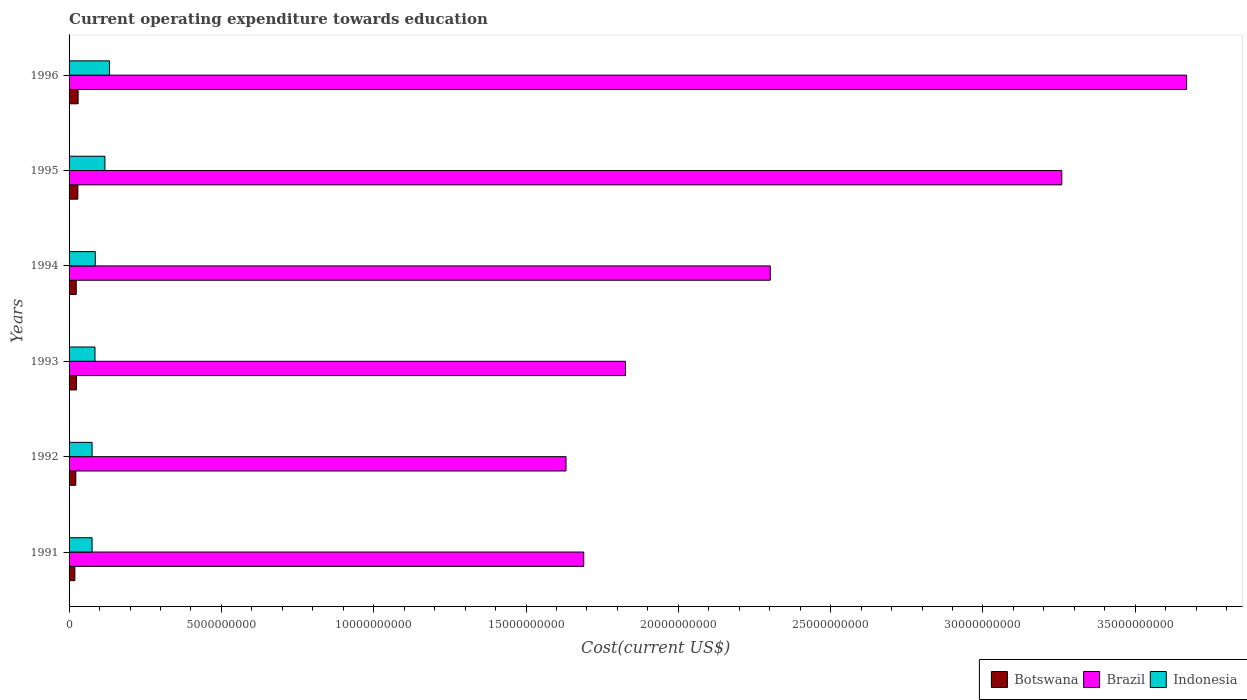Are the number of bars per tick equal to the number of legend labels?
Provide a succinct answer. Yes. Are the number of bars on each tick of the Y-axis equal?
Your answer should be very brief. Yes. What is the label of the 3rd group of bars from the top?
Your answer should be very brief. 1994. What is the expenditure towards education in Botswana in 1993?
Keep it short and to the point. 2.46e+08. Across all years, what is the maximum expenditure towards education in Brazil?
Ensure brevity in your answer.  3.67e+1. Across all years, what is the minimum expenditure towards education in Brazil?
Provide a short and direct response. 1.63e+1. In which year was the expenditure towards education in Indonesia maximum?
Ensure brevity in your answer.  1996. In which year was the expenditure towards education in Botswana minimum?
Ensure brevity in your answer.  1991. What is the total expenditure towards education in Brazil in the graph?
Your answer should be very brief. 1.44e+11. What is the difference between the expenditure towards education in Indonesia in 1993 and that in 1996?
Make the answer very short. -4.77e+08. What is the difference between the expenditure towards education in Indonesia in 1992 and the expenditure towards education in Brazil in 1991?
Your response must be concise. -1.61e+1. What is the average expenditure towards education in Indonesia per year?
Keep it short and to the point. 9.55e+08. In the year 1992, what is the difference between the expenditure towards education in Brazil and expenditure towards education in Indonesia?
Give a very brief answer. 1.56e+1. What is the ratio of the expenditure towards education in Botswana in 1992 to that in 1994?
Keep it short and to the point. 0.94. What is the difference between the highest and the second highest expenditure towards education in Indonesia?
Provide a short and direct response. 1.51e+08. What is the difference between the highest and the lowest expenditure towards education in Botswana?
Offer a terse response. 1.07e+08. Is the sum of the expenditure towards education in Indonesia in 1991 and 1996 greater than the maximum expenditure towards education in Botswana across all years?
Ensure brevity in your answer.  Yes. What does the 2nd bar from the top in 1995 represents?
Provide a succinct answer. Brazil. What does the 1st bar from the bottom in 1992 represents?
Ensure brevity in your answer.  Botswana. Is it the case that in every year, the sum of the expenditure towards education in Indonesia and expenditure towards education in Brazil is greater than the expenditure towards education in Botswana?
Keep it short and to the point. Yes. What is the difference between two consecutive major ticks on the X-axis?
Ensure brevity in your answer.  5.00e+09. Does the graph contain any zero values?
Ensure brevity in your answer.  No. Where does the legend appear in the graph?
Offer a terse response. Bottom right. How are the legend labels stacked?
Your answer should be very brief. Horizontal. What is the title of the graph?
Your answer should be compact. Current operating expenditure towards education. Does "Gabon" appear as one of the legend labels in the graph?
Give a very brief answer. No. What is the label or title of the X-axis?
Your answer should be very brief. Cost(current US$). What is the Cost(current US$) in Botswana in 1991?
Make the answer very short. 1.90e+08. What is the Cost(current US$) of Brazil in 1991?
Make the answer very short. 1.69e+1. What is the Cost(current US$) in Indonesia in 1991?
Ensure brevity in your answer.  7.55e+08. What is the Cost(current US$) in Botswana in 1992?
Offer a terse response. 2.21e+08. What is the Cost(current US$) of Brazil in 1992?
Your answer should be very brief. 1.63e+1. What is the Cost(current US$) of Indonesia in 1992?
Your answer should be compact. 7.56e+08. What is the Cost(current US$) in Botswana in 1993?
Your response must be concise. 2.46e+08. What is the Cost(current US$) of Brazil in 1993?
Provide a succinct answer. 1.83e+1. What is the Cost(current US$) in Indonesia in 1993?
Give a very brief answer. 8.51e+08. What is the Cost(current US$) of Botswana in 1994?
Your answer should be very brief. 2.35e+08. What is the Cost(current US$) in Brazil in 1994?
Provide a succinct answer. 2.30e+1. What is the Cost(current US$) in Indonesia in 1994?
Provide a short and direct response. 8.61e+08. What is the Cost(current US$) in Botswana in 1995?
Your answer should be compact. 2.89e+08. What is the Cost(current US$) of Brazil in 1995?
Make the answer very short. 3.26e+1. What is the Cost(current US$) in Indonesia in 1995?
Offer a terse response. 1.18e+09. What is the Cost(current US$) of Botswana in 1996?
Offer a very short reply. 2.97e+08. What is the Cost(current US$) of Brazil in 1996?
Make the answer very short. 3.67e+1. What is the Cost(current US$) of Indonesia in 1996?
Offer a terse response. 1.33e+09. Across all years, what is the maximum Cost(current US$) of Botswana?
Provide a succinct answer. 2.97e+08. Across all years, what is the maximum Cost(current US$) in Brazil?
Offer a terse response. 3.67e+1. Across all years, what is the maximum Cost(current US$) in Indonesia?
Provide a succinct answer. 1.33e+09. Across all years, what is the minimum Cost(current US$) in Botswana?
Provide a short and direct response. 1.90e+08. Across all years, what is the minimum Cost(current US$) of Brazil?
Your response must be concise. 1.63e+1. Across all years, what is the minimum Cost(current US$) of Indonesia?
Offer a very short reply. 7.55e+08. What is the total Cost(current US$) in Botswana in the graph?
Provide a succinct answer. 1.48e+09. What is the total Cost(current US$) in Brazil in the graph?
Your response must be concise. 1.44e+11. What is the total Cost(current US$) in Indonesia in the graph?
Make the answer very short. 5.73e+09. What is the difference between the Cost(current US$) of Botswana in 1991 and that in 1992?
Make the answer very short. -3.12e+07. What is the difference between the Cost(current US$) of Brazil in 1991 and that in 1992?
Provide a succinct answer. 5.82e+08. What is the difference between the Cost(current US$) of Indonesia in 1991 and that in 1992?
Your answer should be compact. -7.18e+05. What is the difference between the Cost(current US$) of Botswana in 1991 and that in 1993?
Offer a very short reply. -5.54e+07. What is the difference between the Cost(current US$) in Brazil in 1991 and that in 1993?
Offer a terse response. -1.37e+09. What is the difference between the Cost(current US$) of Indonesia in 1991 and that in 1993?
Your response must be concise. -9.61e+07. What is the difference between the Cost(current US$) of Botswana in 1991 and that in 1994?
Offer a terse response. -4.50e+07. What is the difference between the Cost(current US$) of Brazil in 1991 and that in 1994?
Keep it short and to the point. -6.12e+09. What is the difference between the Cost(current US$) of Indonesia in 1991 and that in 1994?
Provide a succinct answer. -1.06e+08. What is the difference between the Cost(current US$) in Botswana in 1991 and that in 1995?
Give a very brief answer. -9.85e+07. What is the difference between the Cost(current US$) in Brazil in 1991 and that in 1995?
Keep it short and to the point. -1.57e+1. What is the difference between the Cost(current US$) in Indonesia in 1991 and that in 1995?
Offer a terse response. -4.22e+08. What is the difference between the Cost(current US$) of Botswana in 1991 and that in 1996?
Your answer should be very brief. -1.07e+08. What is the difference between the Cost(current US$) of Brazil in 1991 and that in 1996?
Offer a very short reply. -1.98e+1. What is the difference between the Cost(current US$) of Indonesia in 1991 and that in 1996?
Your response must be concise. -5.73e+08. What is the difference between the Cost(current US$) of Botswana in 1992 and that in 1993?
Your answer should be very brief. -2.42e+07. What is the difference between the Cost(current US$) in Brazil in 1992 and that in 1993?
Your response must be concise. -1.95e+09. What is the difference between the Cost(current US$) in Indonesia in 1992 and that in 1993?
Provide a succinct answer. -9.54e+07. What is the difference between the Cost(current US$) of Botswana in 1992 and that in 1994?
Your response must be concise. -1.38e+07. What is the difference between the Cost(current US$) of Brazil in 1992 and that in 1994?
Your answer should be compact. -6.71e+09. What is the difference between the Cost(current US$) in Indonesia in 1992 and that in 1994?
Ensure brevity in your answer.  -1.05e+08. What is the difference between the Cost(current US$) of Botswana in 1992 and that in 1995?
Ensure brevity in your answer.  -6.73e+07. What is the difference between the Cost(current US$) of Brazil in 1992 and that in 1995?
Ensure brevity in your answer.  -1.63e+1. What is the difference between the Cost(current US$) in Indonesia in 1992 and that in 1995?
Provide a succinct answer. -4.21e+08. What is the difference between the Cost(current US$) in Botswana in 1992 and that in 1996?
Your response must be concise. -7.54e+07. What is the difference between the Cost(current US$) in Brazil in 1992 and that in 1996?
Make the answer very short. -2.04e+1. What is the difference between the Cost(current US$) of Indonesia in 1992 and that in 1996?
Your answer should be compact. -5.72e+08. What is the difference between the Cost(current US$) of Botswana in 1993 and that in 1994?
Keep it short and to the point. 1.04e+07. What is the difference between the Cost(current US$) of Brazil in 1993 and that in 1994?
Your answer should be very brief. -4.75e+09. What is the difference between the Cost(current US$) of Indonesia in 1993 and that in 1994?
Provide a succinct answer. -9.59e+06. What is the difference between the Cost(current US$) in Botswana in 1993 and that in 1995?
Keep it short and to the point. -4.31e+07. What is the difference between the Cost(current US$) in Brazil in 1993 and that in 1995?
Give a very brief answer. -1.43e+1. What is the difference between the Cost(current US$) in Indonesia in 1993 and that in 1995?
Give a very brief answer. -3.26e+08. What is the difference between the Cost(current US$) of Botswana in 1993 and that in 1996?
Your response must be concise. -5.12e+07. What is the difference between the Cost(current US$) in Brazil in 1993 and that in 1996?
Provide a short and direct response. -1.84e+1. What is the difference between the Cost(current US$) of Indonesia in 1993 and that in 1996?
Your response must be concise. -4.77e+08. What is the difference between the Cost(current US$) of Botswana in 1994 and that in 1995?
Provide a succinct answer. -5.35e+07. What is the difference between the Cost(current US$) of Brazil in 1994 and that in 1995?
Offer a terse response. -9.57e+09. What is the difference between the Cost(current US$) of Indonesia in 1994 and that in 1995?
Ensure brevity in your answer.  -3.16e+08. What is the difference between the Cost(current US$) in Botswana in 1994 and that in 1996?
Offer a terse response. -6.16e+07. What is the difference between the Cost(current US$) in Brazil in 1994 and that in 1996?
Provide a succinct answer. -1.37e+1. What is the difference between the Cost(current US$) of Indonesia in 1994 and that in 1996?
Provide a short and direct response. -4.67e+08. What is the difference between the Cost(current US$) in Botswana in 1995 and that in 1996?
Make the answer very short. -8.13e+06. What is the difference between the Cost(current US$) in Brazil in 1995 and that in 1996?
Make the answer very short. -4.10e+09. What is the difference between the Cost(current US$) in Indonesia in 1995 and that in 1996?
Your answer should be very brief. -1.51e+08. What is the difference between the Cost(current US$) of Botswana in 1991 and the Cost(current US$) of Brazil in 1992?
Offer a terse response. -1.61e+1. What is the difference between the Cost(current US$) of Botswana in 1991 and the Cost(current US$) of Indonesia in 1992?
Offer a terse response. -5.65e+08. What is the difference between the Cost(current US$) of Brazil in 1991 and the Cost(current US$) of Indonesia in 1992?
Your response must be concise. 1.61e+1. What is the difference between the Cost(current US$) of Botswana in 1991 and the Cost(current US$) of Brazil in 1993?
Your response must be concise. -1.81e+1. What is the difference between the Cost(current US$) in Botswana in 1991 and the Cost(current US$) in Indonesia in 1993?
Provide a short and direct response. -6.61e+08. What is the difference between the Cost(current US$) of Brazil in 1991 and the Cost(current US$) of Indonesia in 1993?
Offer a very short reply. 1.60e+1. What is the difference between the Cost(current US$) of Botswana in 1991 and the Cost(current US$) of Brazil in 1994?
Provide a short and direct response. -2.28e+1. What is the difference between the Cost(current US$) in Botswana in 1991 and the Cost(current US$) in Indonesia in 1994?
Your answer should be very brief. -6.70e+08. What is the difference between the Cost(current US$) in Brazil in 1991 and the Cost(current US$) in Indonesia in 1994?
Ensure brevity in your answer.  1.60e+1. What is the difference between the Cost(current US$) in Botswana in 1991 and the Cost(current US$) in Brazil in 1995?
Make the answer very short. -3.24e+1. What is the difference between the Cost(current US$) in Botswana in 1991 and the Cost(current US$) in Indonesia in 1995?
Your answer should be very brief. -9.87e+08. What is the difference between the Cost(current US$) in Brazil in 1991 and the Cost(current US$) in Indonesia in 1995?
Your answer should be compact. 1.57e+1. What is the difference between the Cost(current US$) in Botswana in 1991 and the Cost(current US$) in Brazil in 1996?
Provide a succinct answer. -3.65e+1. What is the difference between the Cost(current US$) in Botswana in 1991 and the Cost(current US$) in Indonesia in 1996?
Provide a succinct answer. -1.14e+09. What is the difference between the Cost(current US$) of Brazil in 1991 and the Cost(current US$) of Indonesia in 1996?
Provide a succinct answer. 1.56e+1. What is the difference between the Cost(current US$) of Botswana in 1992 and the Cost(current US$) of Brazil in 1993?
Your answer should be very brief. -1.80e+1. What is the difference between the Cost(current US$) of Botswana in 1992 and the Cost(current US$) of Indonesia in 1993?
Your response must be concise. -6.30e+08. What is the difference between the Cost(current US$) of Brazil in 1992 and the Cost(current US$) of Indonesia in 1993?
Ensure brevity in your answer.  1.55e+1. What is the difference between the Cost(current US$) of Botswana in 1992 and the Cost(current US$) of Brazil in 1994?
Make the answer very short. -2.28e+1. What is the difference between the Cost(current US$) of Botswana in 1992 and the Cost(current US$) of Indonesia in 1994?
Ensure brevity in your answer.  -6.39e+08. What is the difference between the Cost(current US$) in Brazil in 1992 and the Cost(current US$) in Indonesia in 1994?
Provide a succinct answer. 1.55e+1. What is the difference between the Cost(current US$) of Botswana in 1992 and the Cost(current US$) of Brazil in 1995?
Your answer should be very brief. -3.24e+1. What is the difference between the Cost(current US$) of Botswana in 1992 and the Cost(current US$) of Indonesia in 1995?
Offer a very short reply. -9.56e+08. What is the difference between the Cost(current US$) of Brazil in 1992 and the Cost(current US$) of Indonesia in 1995?
Give a very brief answer. 1.51e+1. What is the difference between the Cost(current US$) of Botswana in 1992 and the Cost(current US$) of Brazil in 1996?
Make the answer very short. -3.65e+1. What is the difference between the Cost(current US$) in Botswana in 1992 and the Cost(current US$) in Indonesia in 1996?
Offer a very short reply. -1.11e+09. What is the difference between the Cost(current US$) in Brazil in 1992 and the Cost(current US$) in Indonesia in 1996?
Keep it short and to the point. 1.50e+1. What is the difference between the Cost(current US$) of Botswana in 1993 and the Cost(current US$) of Brazil in 1994?
Give a very brief answer. -2.28e+1. What is the difference between the Cost(current US$) of Botswana in 1993 and the Cost(current US$) of Indonesia in 1994?
Your answer should be very brief. -6.15e+08. What is the difference between the Cost(current US$) in Brazil in 1993 and the Cost(current US$) in Indonesia in 1994?
Your response must be concise. 1.74e+1. What is the difference between the Cost(current US$) of Botswana in 1993 and the Cost(current US$) of Brazil in 1995?
Provide a short and direct response. -3.23e+1. What is the difference between the Cost(current US$) in Botswana in 1993 and the Cost(current US$) in Indonesia in 1995?
Keep it short and to the point. -9.31e+08. What is the difference between the Cost(current US$) of Brazil in 1993 and the Cost(current US$) of Indonesia in 1995?
Provide a short and direct response. 1.71e+1. What is the difference between the Cost(current US$) of Botswana in 1993 and the Cost(current US$) of Brazil in 1996?
Make the answer very short. -3.64e+1. What is the difference between the Cost(current US$) of Botswana in 1993 and the Cost(current US$) of Indonesia in 1996?
Your answer should be very brief. -1.08e+09. What is the difference between the Cost(current US$) of Brazil in 1993 and the Cost(current US$) of Indonesia in 1996?
Provide a short and direct response. 1.69e+1. What is the difference between the Cost(current US$) of Botswana in 1994 and the Cost(current US$) of Brazil in 1995?
Offer a terse response. -3.24e+1. What is the difference between the Cost(current US$) in Botswana in 1994 and the Cost(current US$) in Indonesia in 1995?
Provide a succinct answer. -9.42e+08. What is the difference between the Cost(current US$) of Brazil in 1994 and the Cost(current US$) of Indonesia in 1995?
Make the answer very short. 2.18e+1. What is the difference between the Cost(current US$) in Botswana in 1994 and the Cost(current US$) in Brazil in 1996?
Give a very brief answer. -3.65e+1. What is the difference between the Cost(current US$) of Botswana in 1994 and the Cost(current US$) of Indonesia in 1996?
Offer a terse response. -1.09e+09. What is the difference between the Cost(current US$) of Brazil in 1994 and the Cost(current US$) of Indonesia in 1996?
Provide a succinct answer. 2.17e+1. What is the difference between the Cost(current US$) of Botswana in 1995 and the Cost(current US$) of Brazil in 1996?
Your response must be concise. -3.64e+1. What is the difference between the Cost(current US$) of Botswana in 1995 and the Cost(current US$) of Indonesia in 1996?
Provide a succinct answer. -1.04e+09. What is the difference between the Cost(current US$) in Brazil in 1995 and the Cost(current US$) in Indonesia in 1996?
Provide a short and direct response. 3.13e+1. What is the average Cost(current US$) of Botswana per year?
Your answer should be very brief. 2.46e+08. What is the average Cost(current US$) in Brazil per year?
Your answer should be very brief. 2.40e+1. What is the average Cost(current US$) of Indonesia per year?
Your response must be concise. 9.55e+08. In the year 1991, what is the difference between the Cost(current US$) in Botswana and Cost(current US$) in Brazil?
Keep it short and to the point. -1.67e+1. In the year 1991, what is the difference between the Cost(current US$) of Botswana and Cost(current US$) of Indonesia?
Your answer should be compact. -5.65e+08. In the year 1991, what is the difference between the Cost(current US$) of Brazil and Cost(current US$) of Indonesia?
Your answer should be compact. 1.61e+1. In the year 1992, what is the difference between the Cost(current US$) in Botswana and Cost(current US$) in Brazil?
Give a very brief answer. -1.61e+1. In the year 1992, what is the difference between the Cost(current US$) in Botswana and Cost(current US$) in Indonesia?
Keep it short and to the point. -5.34e+08. In the year 1992, what is the difference between the Cost(current US$) of Brazil and Cost(current US$) of Indonesia?
Provide a short and direct response. 1.56e+1. In the year 1993, what is the difference between the Cost(current US$) of Botswana and Cost(current US$) of Brazil?
Your answer should be compact. -1.80e+1. In the year 1993, what is the difference between the Cost(current US$) of Botswana and Cost(current US$) of Indonesia?
Your answer should be compact. -6.06e+08. In the year 1993, what is the difference between the Cost(current US$) of Brazil and Cost(current US$) of Indonesia?
Provide a succinct answer. 1.74e+1. In the year 1994, what is the difference between the Cost(current US$) in Botswana and Cost(current US$) in Brazil?
Make the answer very short. -2.28e+1. In the year 1994, what is the difference between the Cost(current US$) of Botswana and Cost(current US$) of Indonesia?
Make the answer very short. -6.25e+08. In the year 1994, what is the difference between the Cost(current US$) in Brazil and Cost(current US$) in Indonesia?
Your answer should be very brief. 2.22e+1. In the year 1995, what is the difference between the Cost(current US$) of Botswana and Cost(current US$) of Brazil?
Give a very brief answer. -3.23e+1. In the year 1995, what is the difference between the Cost(current US$) of Botswana and Cost(current US$) of Indonesia?
Make the answer very short. -8.88e+08. In the year 1995, what is the difference between the Cost(current US$) of Brazil and Cost(current US$) of Indonesia?
Offer a very short reply. 3.14e+1. In the year 1996, what is the difference between the Cost(current US$) in Botswana and Cost(current US$) in Brazil?
Offer a very short reply. -3.64e+1. In the year 1996, what is the difference between the Cost(current US$) of Botswana and Cost(current US$) of Indonesia?
Provide a short and direct response. -1.03e+09. In the year 1996, what is the difference between the Cost(current US$) in Brazil and Cost(current US$) in Indonesia?
Your answer should be compact. 3.54e+1. What is the ratio of the Cost(current US$) in Botswana in 1991 to that in 1992?
Your answer should be very brief. 0.86. What is the ratio of the Cost(current US$) in Brazil in 1991 to that in 1992?
Make the answer very short. 1.04. What is the ratio of the Cost(current US$) of Indonesia in 1991 to that in 1992?
Your response must be concise. 1. What is the ratio of the Cost(current US$) in Botswana in 1991 to that in 1993?
Your answer should be very brief. 0.77. What is the ratio of the Cost(current US$) in Brazil in 1991 to that in 1993?
Your response must be concise. 0.93. What is the ratio of the Cost(current US$) in Indonesia in 1991 to that in 1993?
Keep it short and to the point. 0.89. What is the ratio of the Cost(current US$) of Botswana in 1991 to that in 1994?
Keep it short and to the point. 0.81. What is the ratio of the Cost(current US$) of Brazil in 1991 to that in 1994?
Provide a succinct answer. 0.73. What is the ratio of the Cost(current US$) in Indonesia in 1991 to that in 1994?
Your response must be concise. 0.88. What is the ratio of the Cost(current US$) in Botswana in 1991 to that in 1995?
Ensure brevity in your answer.  0.66. What is the ratio of the Cost(current US$) of Brazil in 1991 to that in 1995?
Your response must be concise. 0.52. What is the ratio of the Cost(current US$) of Indonesia in 1991 to that in 1995?
Give a very brief answer. 0.64. What is the ratio of the Cost(current US$) of Botswana in 1991 to that in 1996?
Your answer should be very brief. 0.64. What is the ratio of the Cost(current US$) in Brazil in 1991 to that in 1996?
Your response must be concise. 0.46. What is the ratio of the Cost(current US$) of Indonesia in 1991 to that in 1996?
Provide a short and direct response. 0.57. What is the ratio of the Cost(current US$) in Botswana in 1992 to that in 1993?
Offer a terse response. 0.9. What is the ratio of the Cost(current US$) in Brazil in 1992 to that in 1993?
Ensure brevity in your answer.  0.89. What is the ratio of the Cost(current US$) of Indonesia in 1992 to that in 1993?
Provide a succinct answer. 0.89. What is the ratio of the Cost(current US$) of Botswana in 1992 to that in 1994?
Provide a succinct answer. 0.94. What is the ratio of the Cost(current US$) in Brazil in 1992 to that in 1994?
Give a very brief answer. 0.71. What is the ratio of the Cost(current US$) of Indonesia in 1992 to that in 1994?
Your response must be concise. 0.88. What is the ratio of the Cost(current US$) in Botswana in 1992 to that in 1995?
Offer a very short reply. 0.77. What is the ratio of the Cost(current US$) of Brazil in 1992 to that in 1995?
Give a very brief answer. 0.5. What is the ratio of the Cost(current US$) of Indonesia in 1992 to that in 1995?
Your answer should be very brief. 0.64. What is the ratio of the Cost(current US$) of Botswana in 1992 to that in 1996?
Give a very brief answer. 0.75. What is the ratio of the Cost(current US$) in Brazil in 1992 to that in 1996?
Your response must be concise. 0.44. What is the ratio of the Cost(current US$) in Indonesia in 1992 to that in 1996?
Provide a short and direct response. 0.57. What is the ratio of the Cost(current US$) of Botswana in 1993 to that in 1994?
Make the answer very short. 1.04. What is the ratio of the Cost(current US$) in Brazil in 1993 to that in 1994?
Offer a very short reply. 0.79. What is the ratio of the Cost(current US$) of Indonesia in 1993 to that in 1994?
Provide a short and direct response. 0.99. What is the ratio of the Cost(current US$) of Botswana in 1993 to that in 1995?
Keep it short and to the point. 0.85. What is the ratio of the Cost(current US$) in Brazil in 1993 to that in 1995?
Offer a terse response. 0.56. What is the ratio of the Cost(current US$) of Indonesia in 1993 to that in 1995?
Offer a very short reply. 0.72. What is the ratio of the Cost(current US$) in Botswana in 1993 to that in 1996?
Offer a terse response. 0.83. What is the ratio of the Cost(current US$) in Brazil in 1993 to that in 1996?
Offer a terse response. 0.5. What is the ratio of the Cost(current US$) of Indonesia in 1993 to that in 1996?
Your answer should be compact. 0.64. What is the ratio of the Cost(current US$) in Botswana in 1994 to that in 1995?
Offer a very short reply. 0.81. What is the ratio of the Cost(current US$) in Brazil in 1994 to that in 1995?
Give a very brief answer. 0.71. What is the ratio of the Cost(current US$) of Indonesia in 1994 to that in 1995?
Offer a very short reply. 0.73. What is the ratio of the Cost(current US$) of Botswana in 1994 to that in 1996?
Ensure brevity in your answer.  0.79. What is the ratio of the Cost(current US$) of Brazil in 1994 to that in 1996?
Provide a short and direct response. 0.63. What is the ratio of the Cost(current US$) in Indonesia in 1994 to that in 1996?
Offer a terse response. 0.65. What is the ratio of the Cost(current US$) in Botswana in 1995 to that in 1996?
Keep it short and to the point. 0.97. What is the ratio of the Cost(current US$) of Brazil in 1995 to that in 1996?
Make the answer very short. 0.89. What is the ratio of the Cost(current US$) of Indonesia in 1995 to that in 1996?
Make the answer very short. 0.89. What is the difference between the highest and the second highest Cost(current US$) of Botswana?
Your answer should be compact. 8.13e+06. What is the difference between the highest and the second highest Cost(current US$) in Brazil?
Give a very brief answer. 4.10e+09. What is the difference between the highest and the second highest Cost(current US$) of Indonesia?
Offer a terse response. 1.51e+08. What is the difference between the highest and the lowest Cost(current US$) in Botswana?
Provide a short and direct response. 1.07e+08. What is the difference between the highest and the lowest Cost(current US$) in Brazil?
Provide a succinct answer. 2.04e+1. What is the difference between the highest and the lowest Cost(current US$) in Indonesia?
Give a very brief answer. 5.73e+08. 